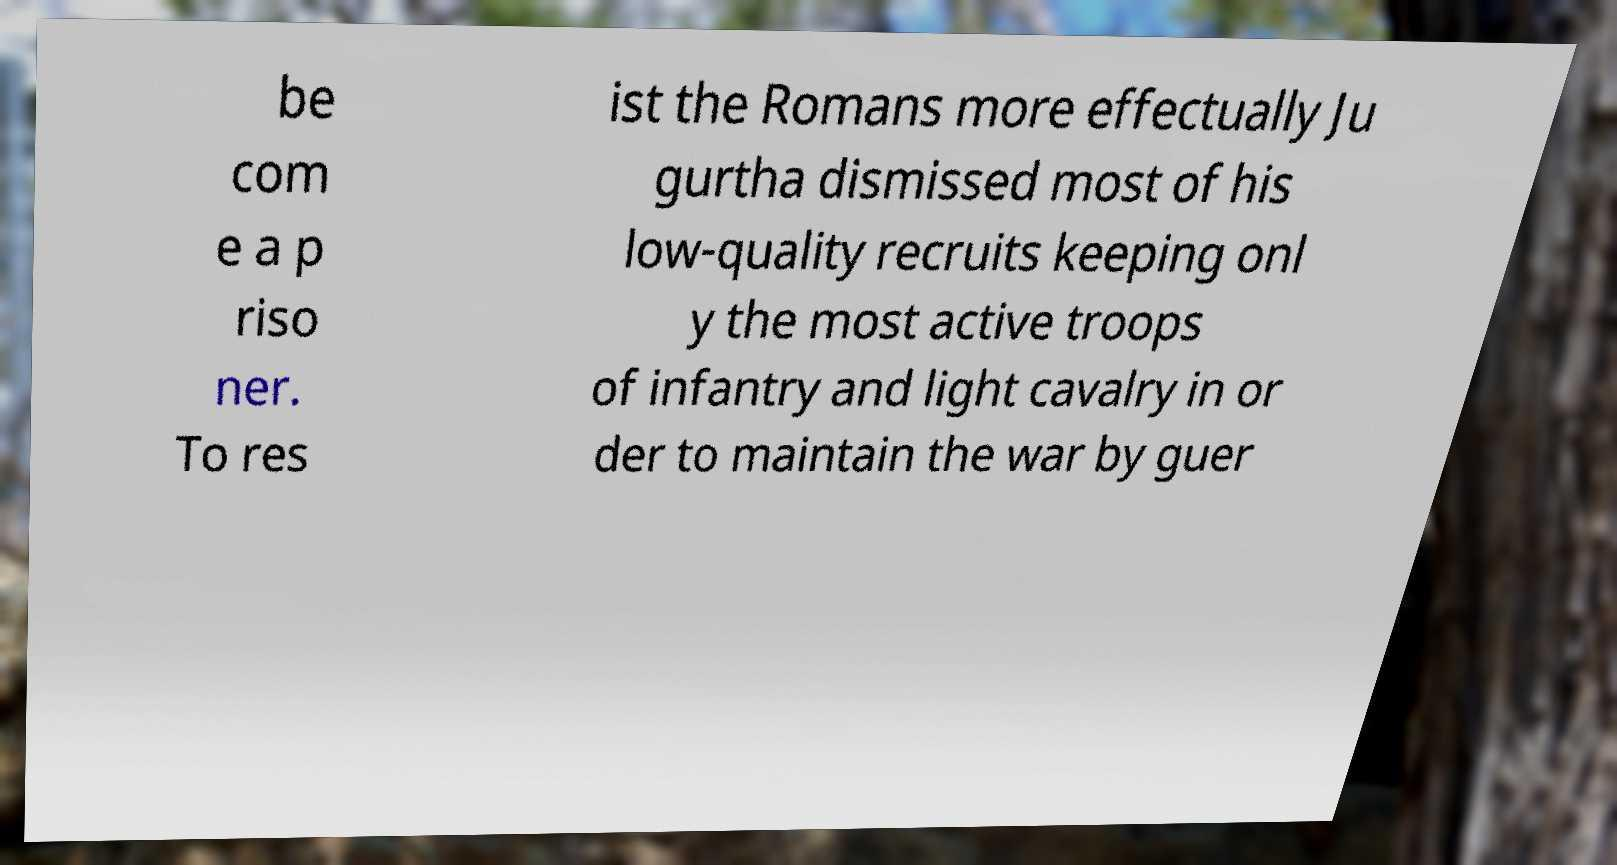Could you extract and type out the text from this image? be com e a p riso ner. To res ist the Romans more effectually Ju gurtha dismissed most of his low-quality recruits keeping onl y the most active troops of infantry and light cavalry in or der to maintain the war by guer 